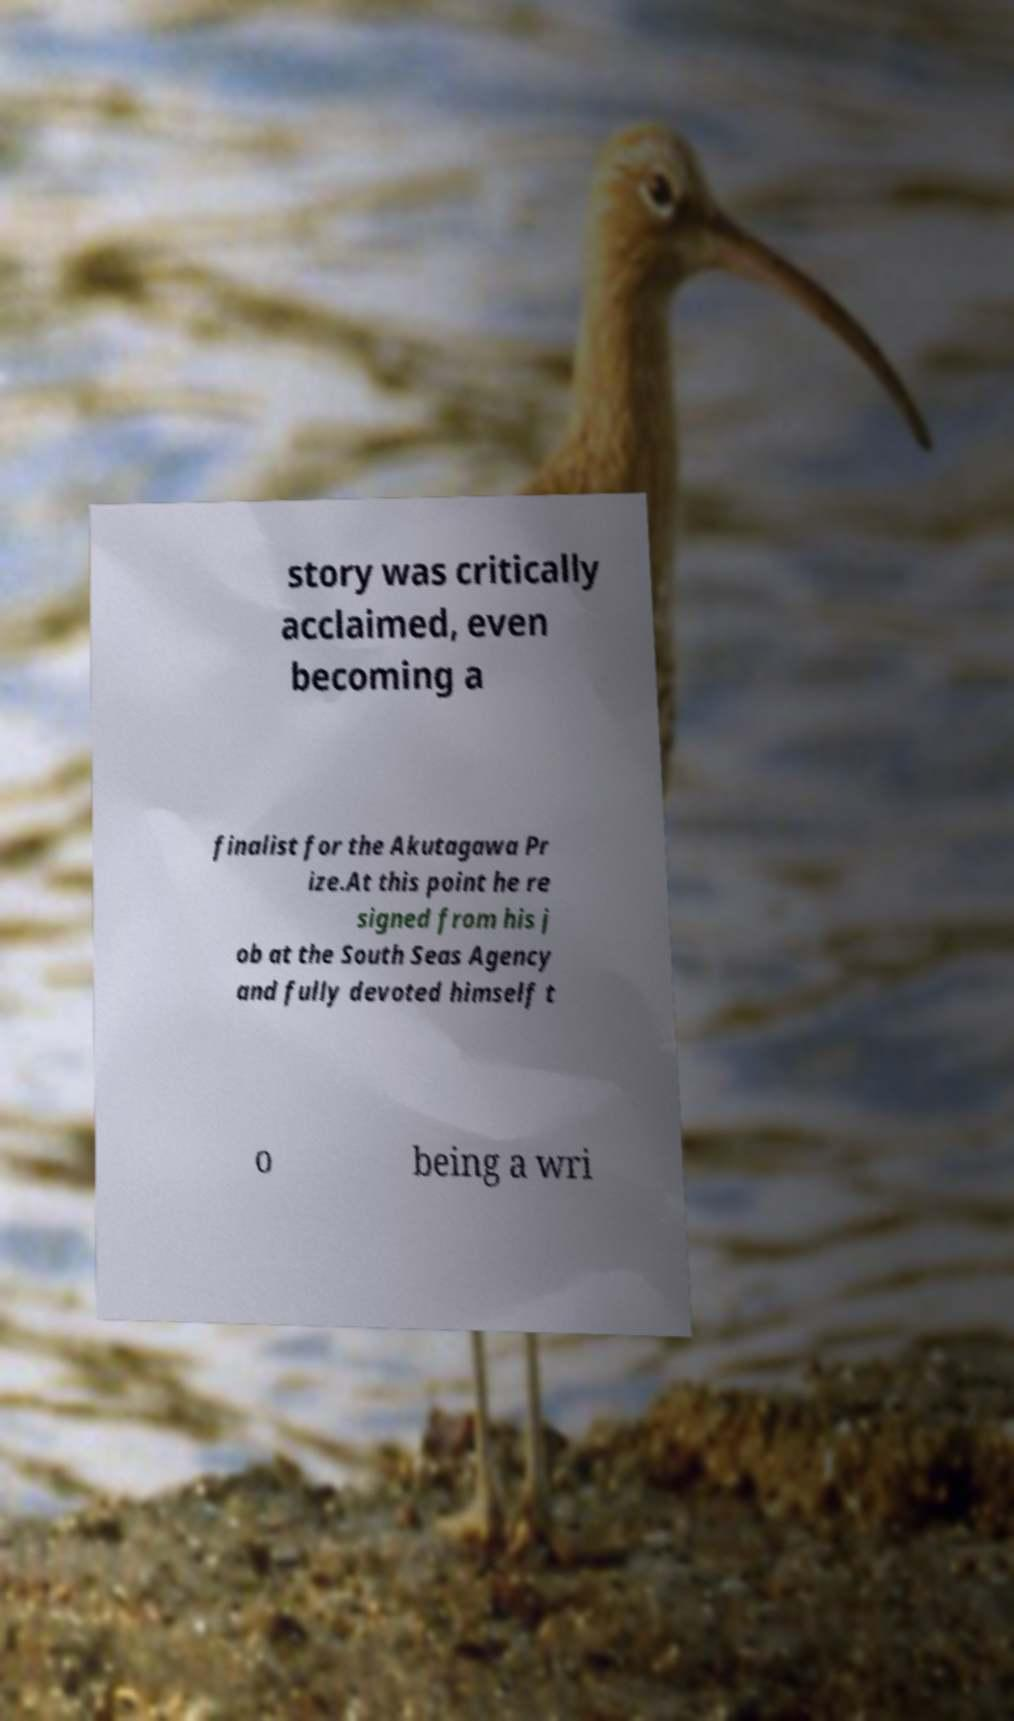There's text embedded in this image that I need extracted. Can you transcribe it verbatim? story was critically acclaimed, even becoming a finalist for the Akutagawa Pr ize.At this point he re signed from his j ob at the South Seas Agency and fully devoted himself t o being a wri 